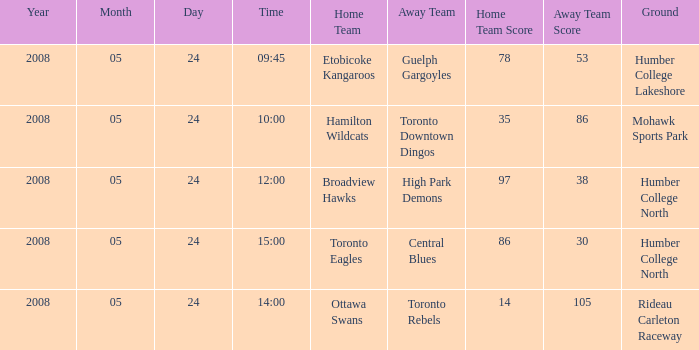Who was the home team of the game at the time of 15:00? Toronto Eagles. 